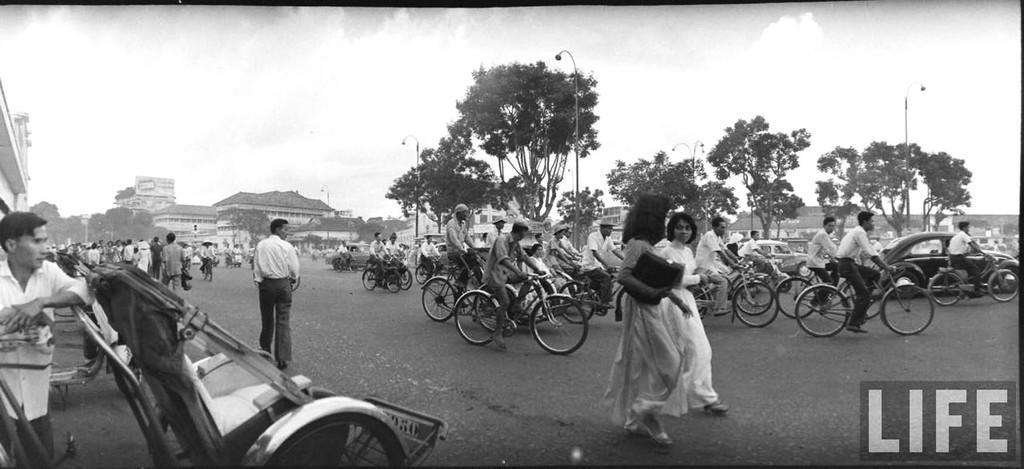Describe this image in one or two sentences. In this image two women are walking on the road. At the left side there is a person leaning on vehicle. Few persons are riding on bicycles. There are few other vehicles on the road. Few persons at the left side are walking. At the background there are some trees, houses and sky. 